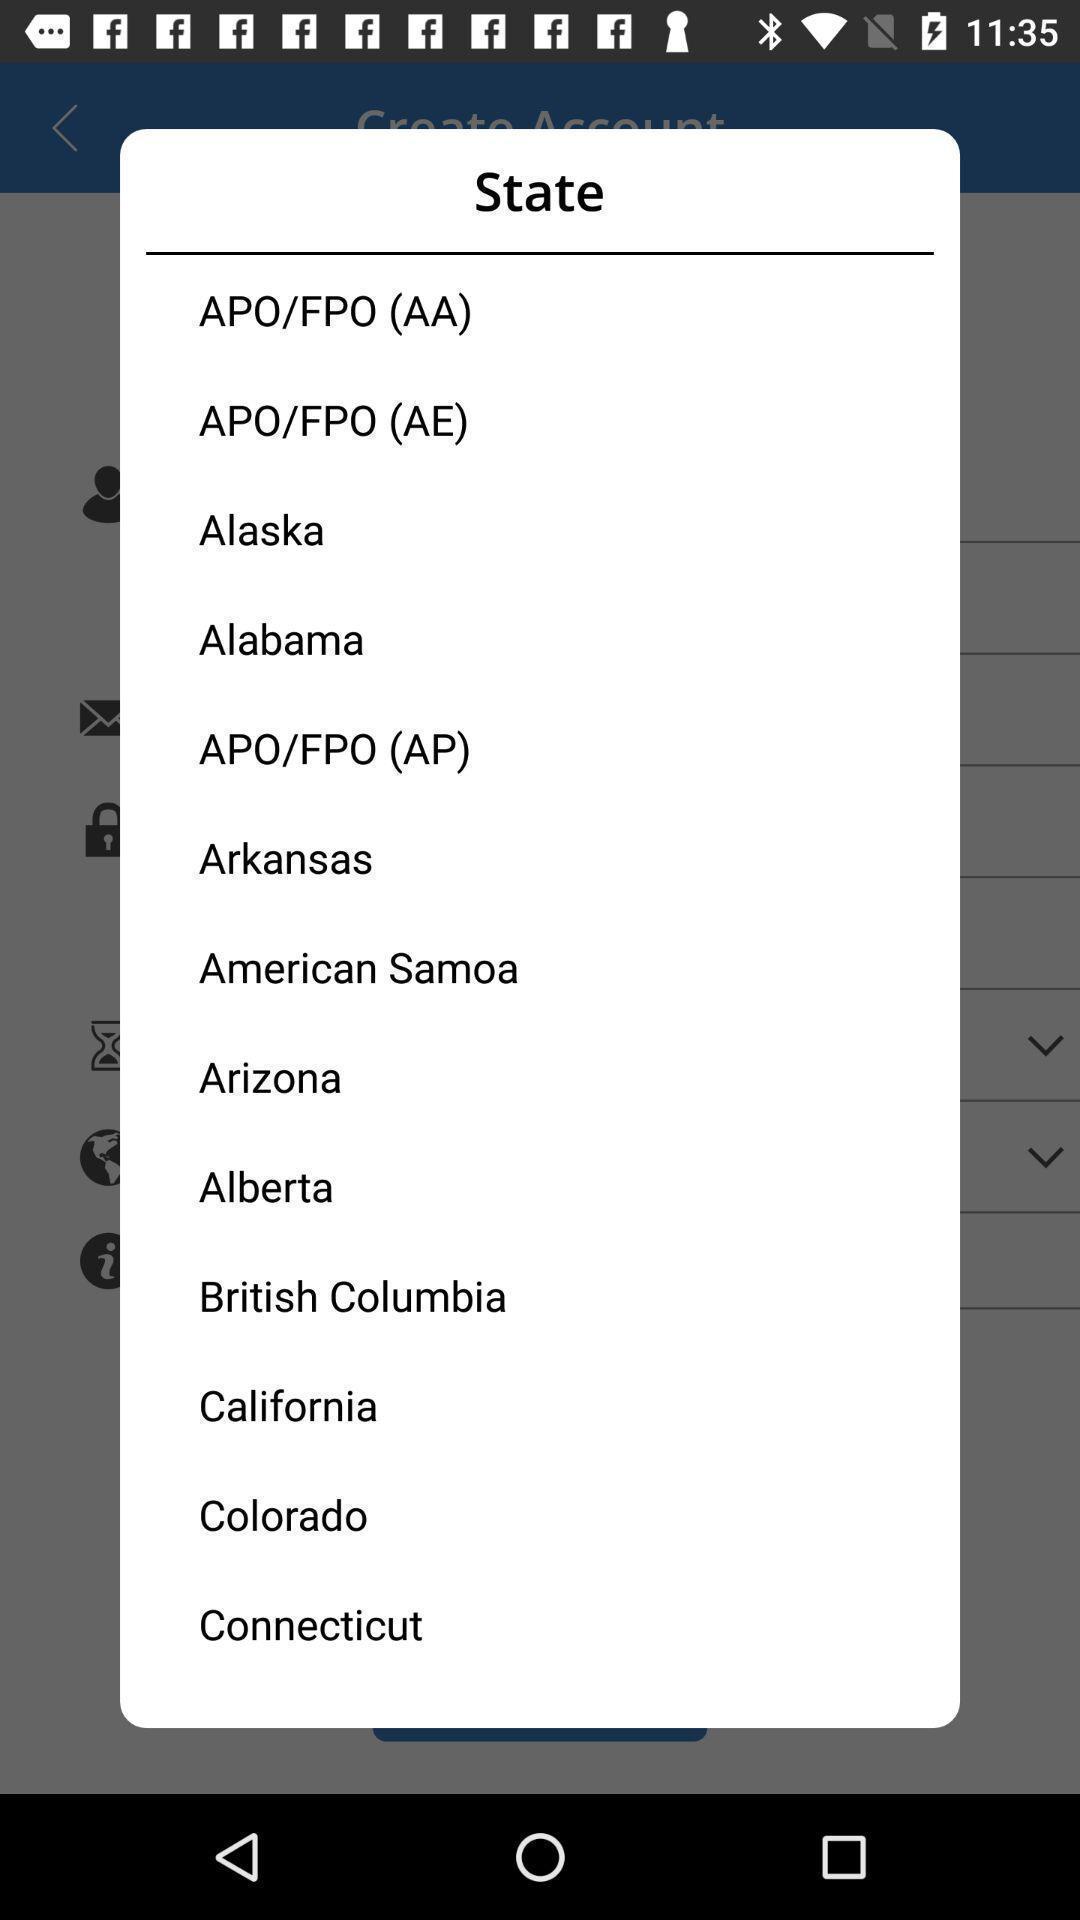What details can you identify in this image? Pop-up showing to select state. 